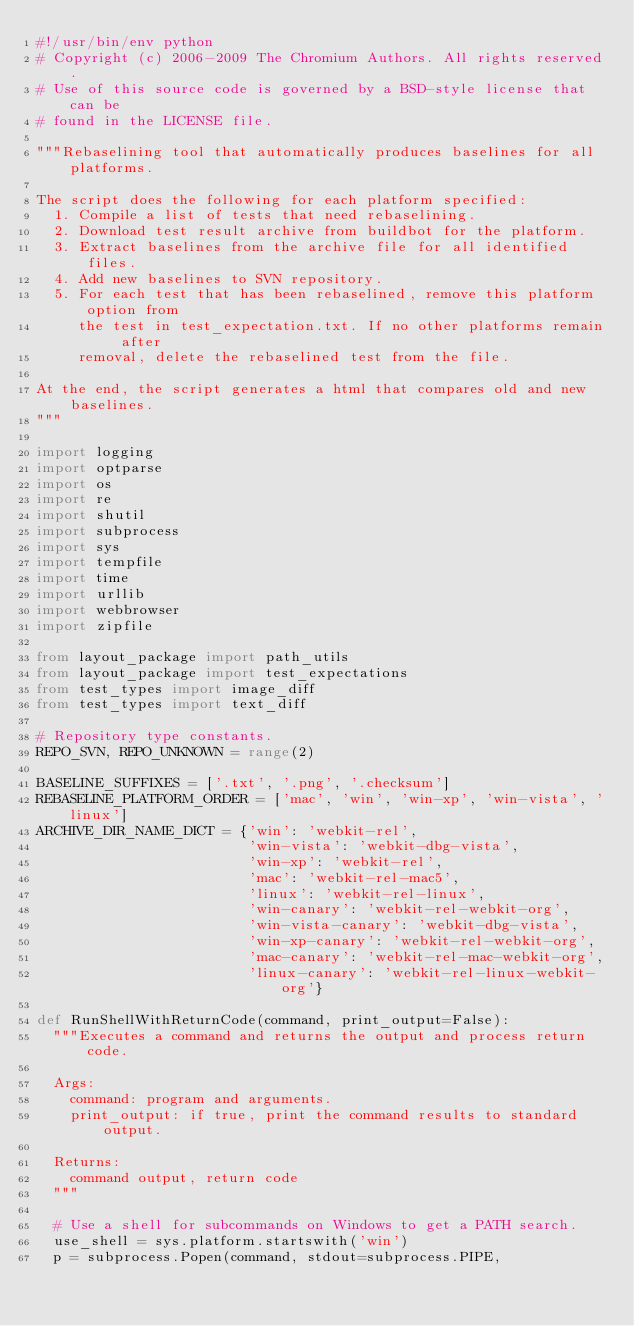Convert code to text. <code><loc_0><loc_0><loc_500><loc_500><_Python_>#!/usr/bin/env python
# Copyright (c) 2006-2009 The Chromium Authors. All rights reserved.
# Use of this source code is governed by a BSD-style license that can be
# found in the LICENSE file.

"""Rebaselining tool that automatically produces baselines for all platforms.

The script does the following for each platform specified:
  1. Compile a list of tests that need rebaselining.
  2. Download test result archive from buildbot for the platform.
  3. Extract baselines from the archive file for all identified files.
  4. Add new baselines to SVN repository.
  5. For each test that has been rebaselined, remove this platform option from
     the test in test_expectation.txt. If no other platforms remain after
     removal, delete the rebaselined test from the file.

At the end, the script generates a html that compares old and new baselines.
"""

import logging
import optparse
import os
import re
import shutil
import subprocess
import sys
import tempfile
import time
import urllib
import webbrowser
import zipfile

from layout_package import path_utils
from layout_package import test_expectations
from test_types import image_diff
from test_types import text_diff

# Repository type constants.
REPO_SVN, REPO_UNKNOWN = range(2)

BASELINE_SUFFIXES = ['.txt', '.png', '.checksum']
REBASELINE_PLATFORM_ORDER = ['mac', 'win', 'win-xp', 'win-vista', 'linux']
ARCHIVE_DIR_NAME_DICT = {'win': 'webkit-rel',
                         'win-vista': 'webkit-dbg-vista',
                         'win-xp': 'webkit-rel',
                         'mac': 'webkit-rel-mac5',
                         'linux': 'webkit-rel-linux',
                         'win-canary': 'webkit-rel-webkit-org',
                         'win-vista-canary': 'webkit-dbg-vista',
                         'win-xp-canary': 'webkit-rel-webkit-org',
                         'mac-canary': 'webkit-rel-mac-webkit-org',
                         'linux-canary': 'webkit-rel-linux-webkit-org'}

def RunShellWithReturnCode(command, print_output=False):
  """Executes a command and returns the output and process return code.

  Args:
    command: program and arguments.
    print_output: if true, print the command results to standard output.

  Returns:
    command output, return code
  """

  # Use a shell for subcommands on Windows to get a PATH search.
  use_shell = sys.platform.startswith('win')
  p = subprocess.Popen(command, stdout=subprocess.PIPE,</code> 